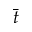<formula> <loc_0><loc_0><loc_500><loc_500>\bar { t }</formula> 